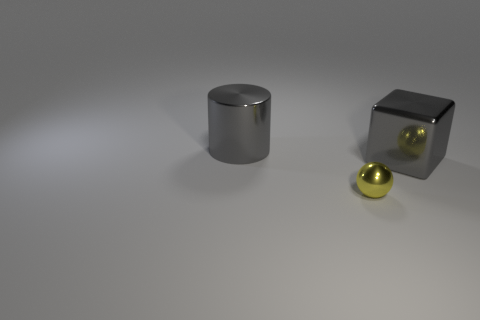Add 3 big yellow rubber cylinders. How many objects exist? 6 Subtract all spheres. How many objects are left? 2 Add 3 small yellow metal spheres. How many small yellow metal spheres are left? 4 Add 2 big blue shiny balls. How many big blue shiny balls exist? 2 Subtract 0 purple spheres. How many objects are left? 3 Subtract all yellow cylinders. Subtract all blue balls. How many cylinders are left? 1 Subtract all purple objects. Subtract all small metallic spheres. How many objects are left? 2 